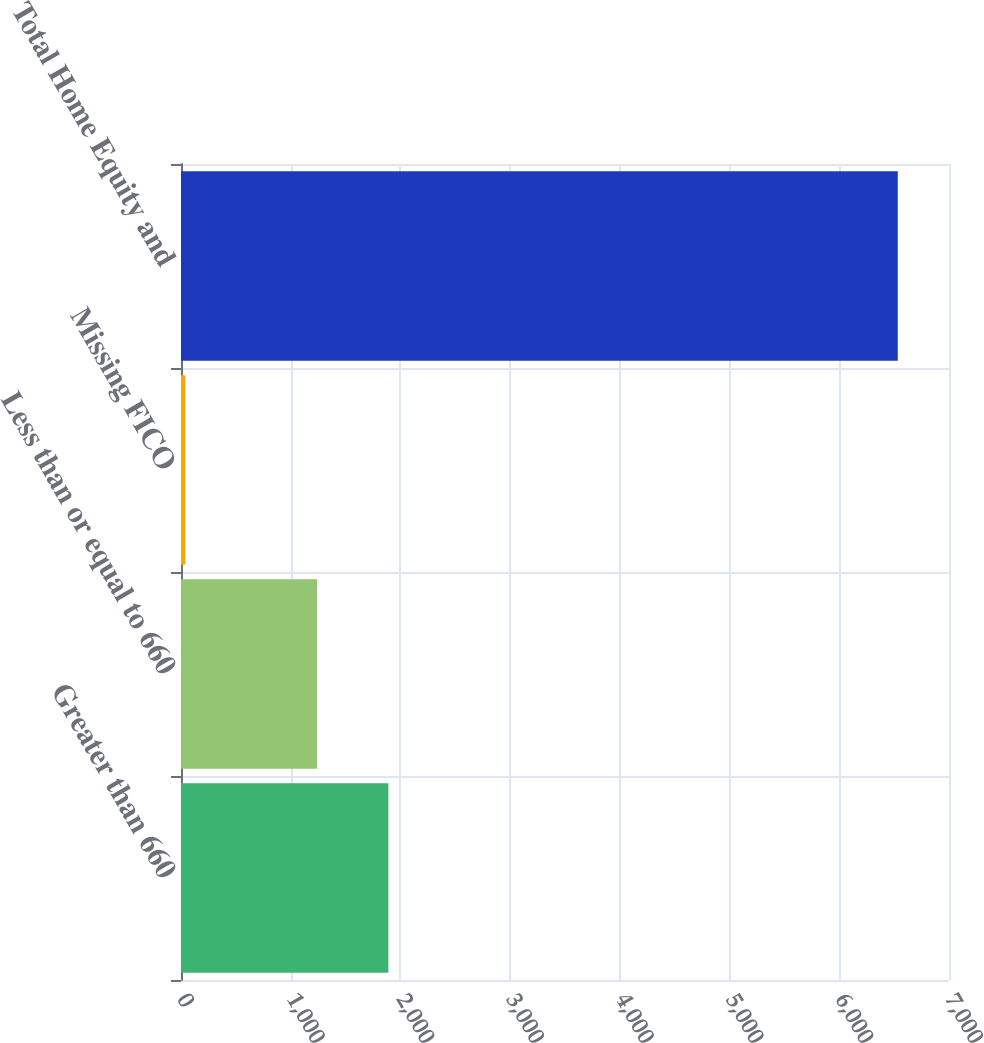<chart> <loc_0><loc_0><loc_500><loc_500><bar_chart><fcel>Greater than 660<fcel>Less than or equal to 660<fcel>Missing FICO<fcel>Total Home Equity and<nl><fcel>1890.4<fcel>1241<fcel>39<fcel>6533<nl></chart> 